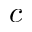Convert formula to latex. <formula><loc_0><loc_0><loc_500><loc_500>c</formula> 